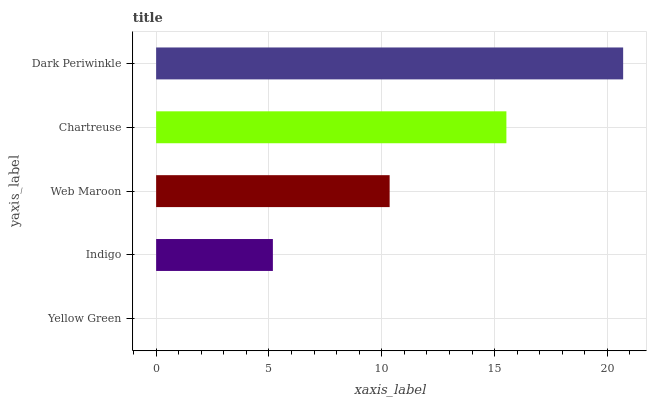Is Yellow Green the minimum?
Answer yes or no. Yes. Is Dark Periwinkle the maximum?
Answer yes or no. Yes. Is Indigo the minimum?
Answer yes or no. No. Is Indigo the maximum?
Answer yes or no. No. Is Indigo greater than Yellow Green?
Answer yes or no. Yes. Is Yellow Green less than Indigo?
Answer yes or no. Yes. Is Yellow Green greater than Indigo?
Answer yes or no. No. Is Indigo less than Yellow Green?
Answer yes or no. No. Is Web Maroon the high median?
Answer yes or no. Yes. Is Web Maroon the low median?
Answer yes or no. Yes. Is Chartreuse the high median?
Answer yes or no. No. Is Yellow Green the low median?
Answer yes or no. No. 